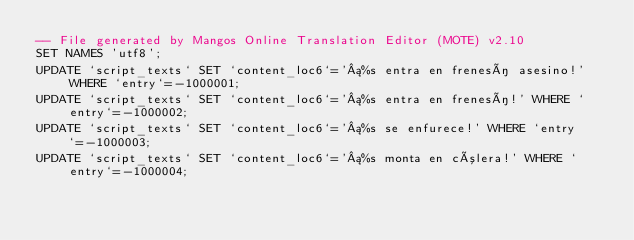Convert code to text. <code><loc_0><loc_0><loc_500><loc_500><_SQL_>-- File generated by Mangos Online Translation Editor (MOTE) v2.10
SET NAMES 'utf8';
UPDATE `script_texts` SET `content_loc6`='¡%s entra en frenesí asesino!' WHERE `entry`=-1000001;
UPDATE `script_texts` SET `content_loc6`='¡%s entra en frenesí!' WHERE `entry`=-1000002;
UPDATE `script_texts` SET `content_loc6`='¡%s se enfurece!' WHERE `entry`=-1000003;
UPDATE `script_texts` SET `content_loc6`='¡%s monta en cólera!' WHERE `entry`=-1000004;</code> 